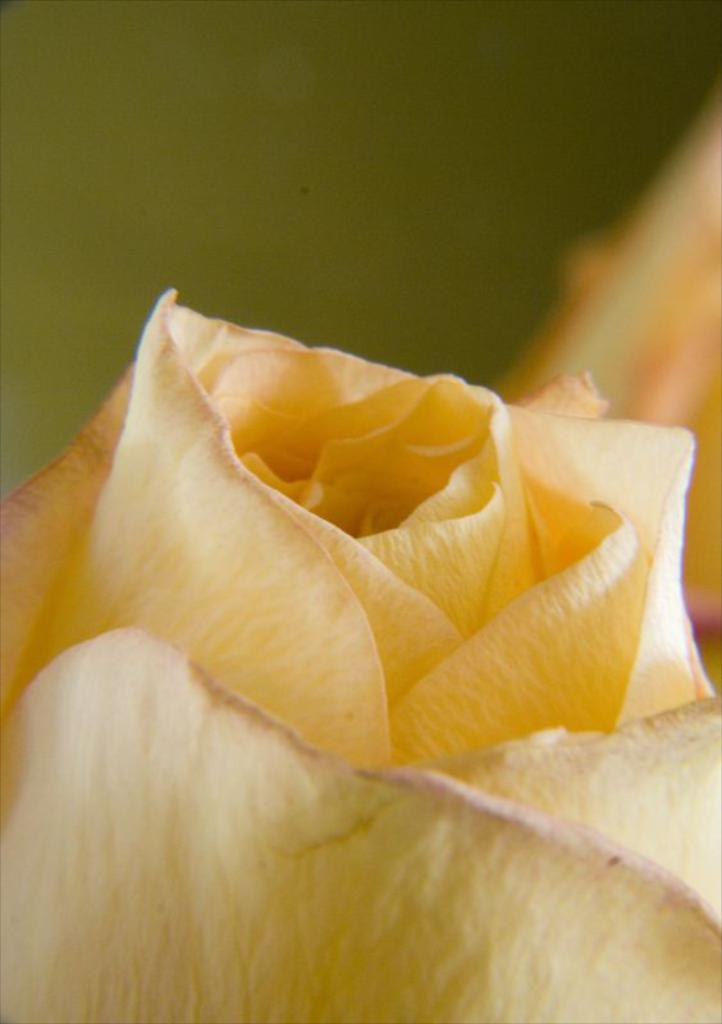What is the main subject in the foreground of the image? There is a yellow color flower in the foreground of the image. What can be seen in the background of the image? There are other objects visible in the background of the image. What type of string is attached to the leg of the flower in the image? There is no string or leg present in the image; it features a yellow color flower in the foreground and other objects in the background. 